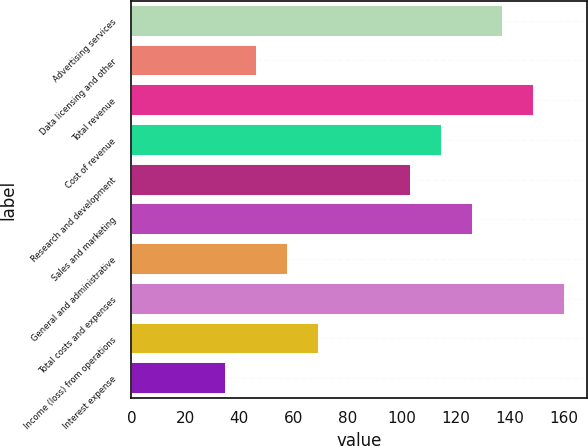Convert chart. <chart><loc_0><loc_0><loc_500><loc_500><bar_chart><fcel>Advertising services<fcel>Data licensing and other<fcel>Total revenue<fcel>Cost of revenue<fcel>Research and development<fcel>Sales and marketing<fcel>General and administrative<fcel>Total costs and expenses<fcel>Income (loss) from operations<fcel>Interest expense<nl><fcel>137.8<fcel>46.6<fcel>149.2<fcel>115<fcel>103.6<fcel>126.4<fcel>58<fcel>160.6<fcel>69.4<fcel>35.2<nl></chart> 